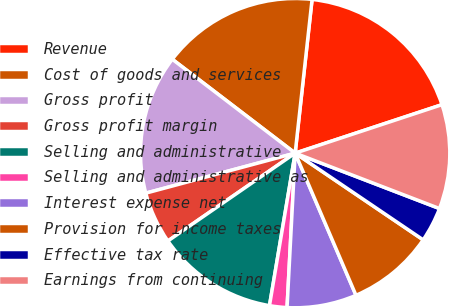Convert chart. <chart><loc_0><loc_0><loc_500><loc_500><pie_chart><fcel>Revenue<fcel>Cost of goods and services<fcel>Gross profit<fcel>Gross profit margin<fcel>Selling and administrative<fcel>Selling and administrative as<fcel>Interest expense net<fcel>Provision for income taxes<fcel>Effective tax rate<fcel>Earnings from continuing<nl><fcel>18.18%<fcel>16.36%<fcel>14.55%<fcel>5.45%<fcel>12.73%<fcel>1.82%<fcel>7.27%<fcel>9.09%<fcel>3.64%<fcel>10.91%<nl></chart> 